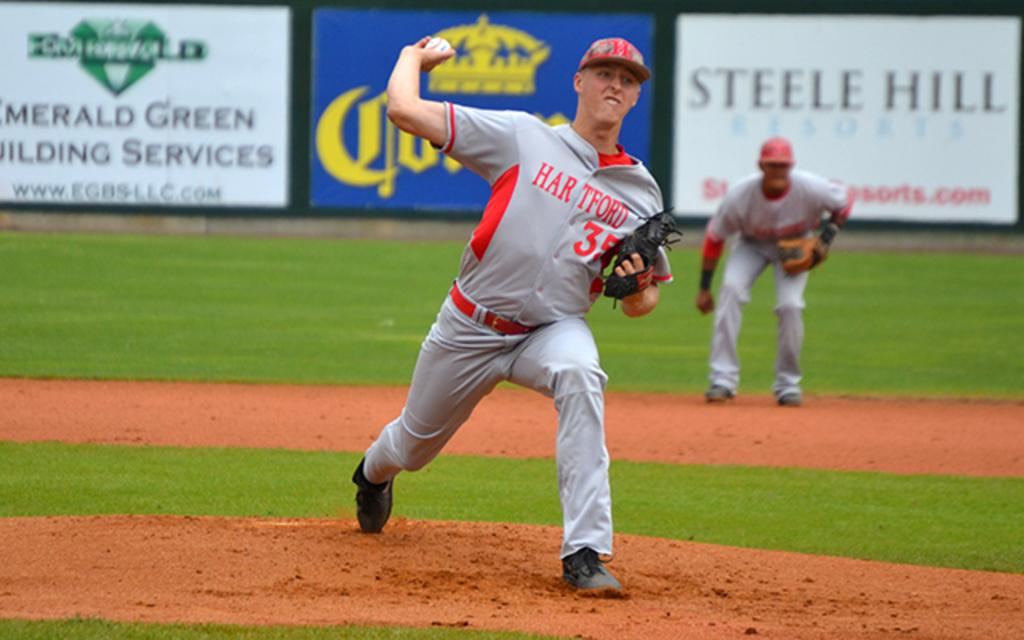Provide a one-sentence caption for the provided image. hartford player #35 pitches the ball in front of sponsor signs for steele hill resorts and emerald green building services. 